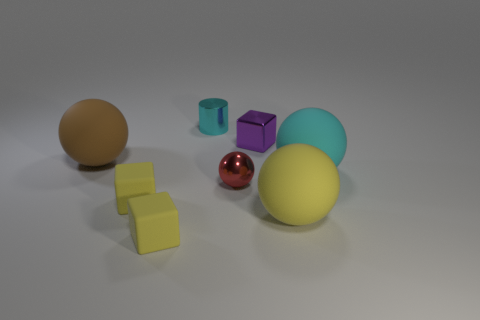What number of other things are there of the same size as the red shiny thing?
Your answer should be very brief. 4. There is a object that is the same color as the cylinder; what size is it?
Make the answer very short. Large. What material is the object on the right side of the yellow rubber thing that is to the right of the small purple metal thing made of?
Provide a short and direct response. Rubber. Are there any spheres left of the small cylinder?
Make the answer very short. Yes. Is the number of small cyan metallic objects that are on the left side of the yellow rubber sphere greater than the number of blue matte blocks?
Offer a terse response. Yes. Is there a thing of the same color as the small shiny cylinder?
Give a very brief answer. Yes. There is a metallic cylinder that is the same size as the shiny ball; what color is it?
Make the answer very short. Cyan. Is there a cylinder that is behind the tiny metal object behind the small purple thing?
Give a very brief answer. No. What is the large object on the left side of the purple block made of?
Give a very brief answer. Rubber. Are the big object that is to the left of the tiny purple thing and the cube that is behind the shiny ball made of the same material?
Offer a terse response. No. 